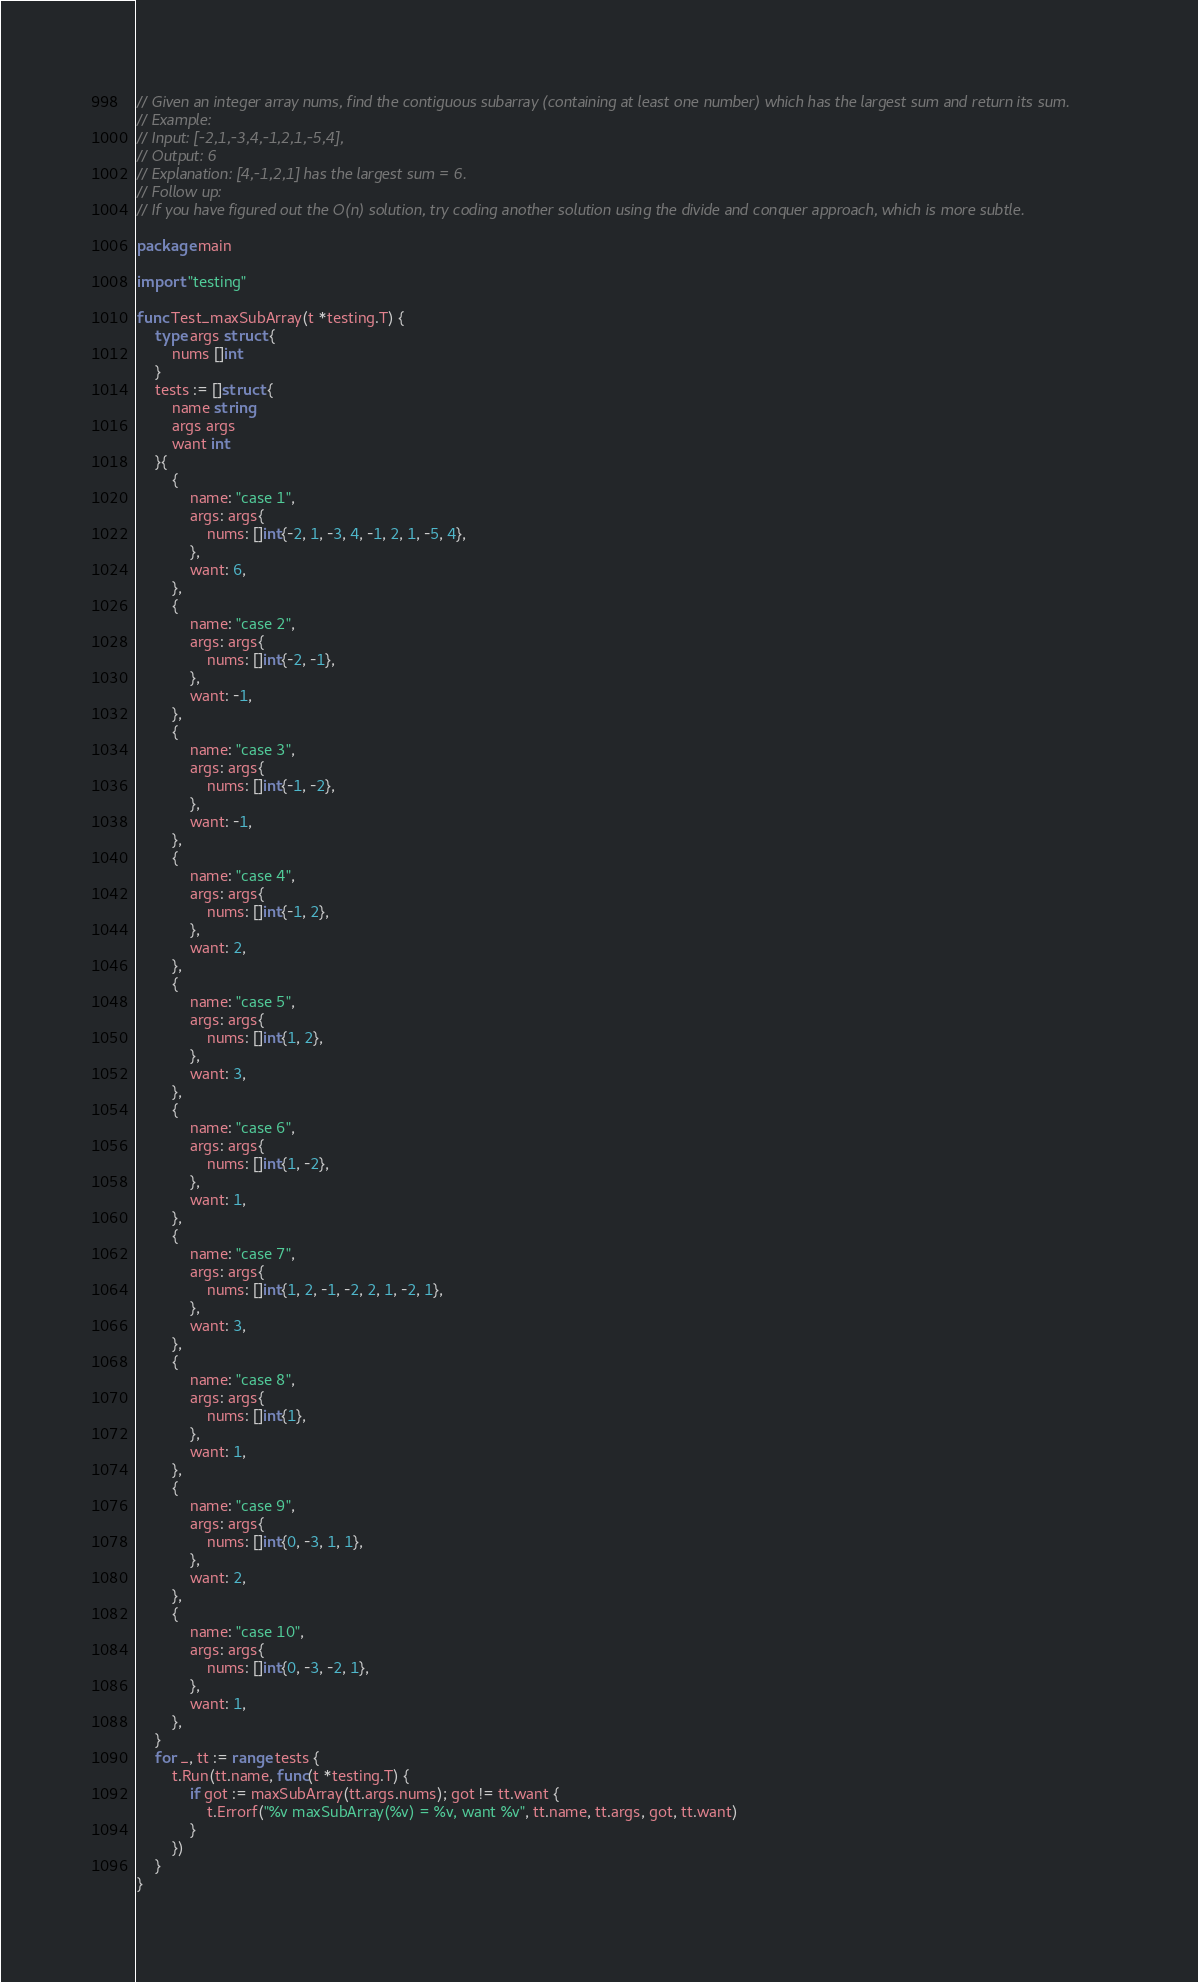<code> <loc_0><loc_0><loc_500><loc_500><_Go_>// Given an integer array nums, find the contiguous subarray (containing at least one number) which has the largest sum and return its sum.
// Example:
// Input: [-2,1,-3,4,-1,2,1,-5,4],
// Output: 6
// Explanation: [4,-1,2,1] has the largest sum = 6.
// Follow up:
// If you have figured out the O(n) solution, try coding another solution using the divide and conquer approach, which is more subtle.

package main

import "testing"

func Test_maxSubArray(t *testing.T) {
	type args struct {
		nums []int
	}
	tests := []struct {
		name string
		args args
		want int
	}{
		{
			name: "case 1",
			args: args{
				nums: []int{-2, 1, -3, 4, -1, 2, 1, -5, 4},
			},
			want: 6,
		},
		{
			name: "case 2",
			args: args{
				nums: []int{-2, -1},
			},
			want: -1,
		},
		{
			name: "case 3",
			args: args{
				nums: []int{-1, -2},
			},
			want: -1,
		},
		{
			name: "case 4",
			args: args{
				nums: []int{-1, 2},
			},
			want: 2,
		},
		{
			name: "case 5",
			args: args{
				nums: []int{1, 2},
			},
			want: 3,
		},
		{
			name: "case 6",
			args: args{
				nums: []int{1, -2},
			},
			want: 1,
		},
		{
			name: "case 7",
			args: args{
				nums: []int{1, 2, -1, -2, 2, 1, -2, 1},
			},
			want: 3,
		},
		{
			name: "case 8",
			args: args{
				nums: []int{1},
			},
			want: 1,
		},
		{
			name: "case 9",
			args: args{
				nums: []int{0, -3, 1, 1},
			},
			want: 2,
		},
		{
			name: "case 10",
			args: args{
				nums: []int{0, -3, -2, 1},
			},
			want: 1,
		},
	}
	for _, tt := range tests {
		t.Run(tt.name, func(t *testing.T) {
			if got := maxSubArray(tt.args.nums); got != tt.want {
				t.Errorf("%v maxSubArray(%v) = %v, want %v", tt.name, tt.args, got, tt.want)
			}
		})
	}
}
</code> 